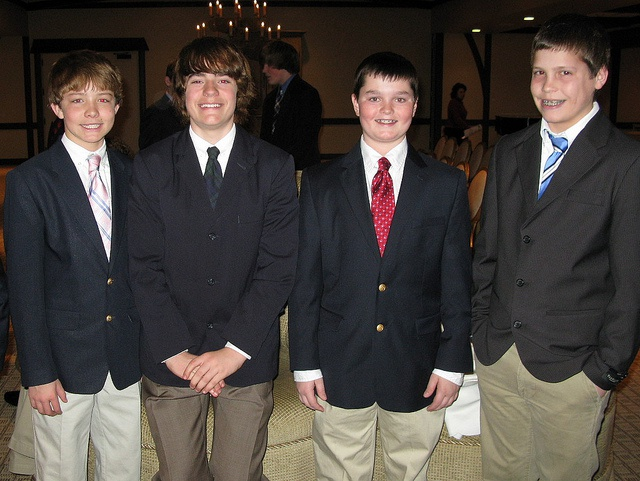Describe the objects in this image and their specific colors. I can see people in black, gray, and tan tones, people in black, darkgray, tan, and white tones, people in black, gray, and tan tones, people in black, darkgray, lightgray, and tan tones, and couch in black, tan, lightgray, and gray tones in this image. 